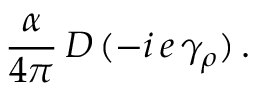Convert formula to latex. <formula><loc_0><loc_0><loc_500><loc_500>\frac { \alpha } { 4 \pi } \, D \, ( - i \, e \, \gamma _ { \rho } ) \, .</formula> 